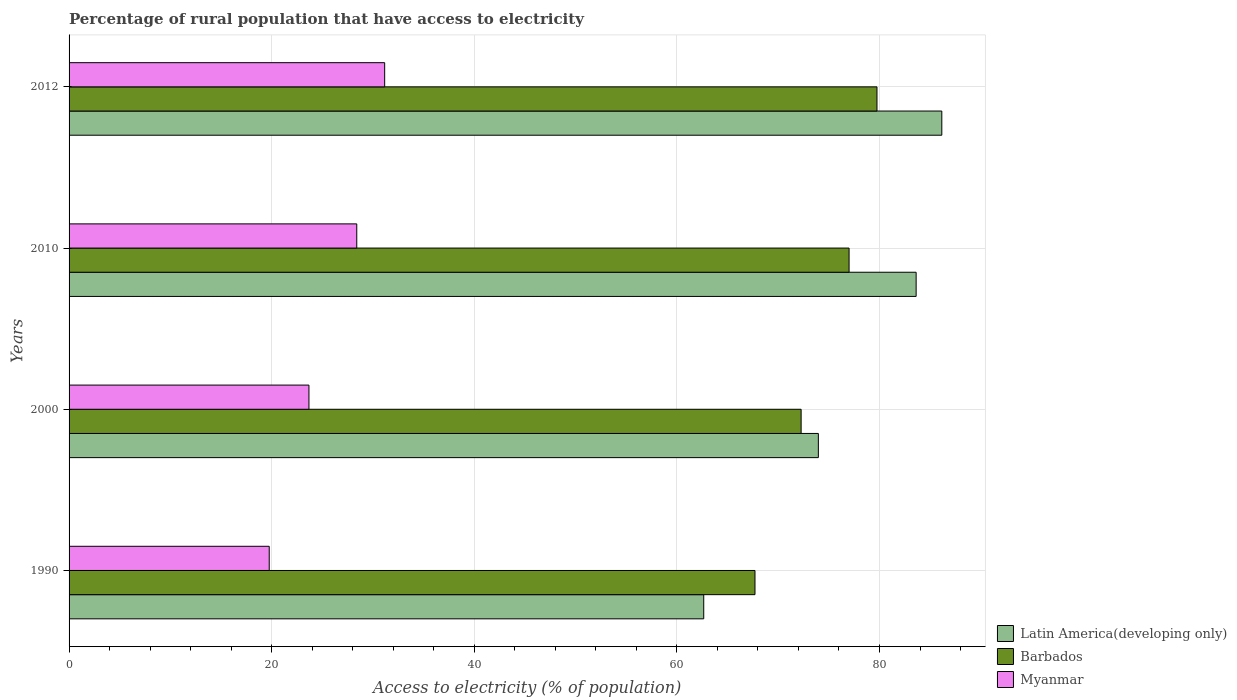How many bars are there on the 2nd tick from the top?
Your response must be concise. 3. How many bars are there on the 4th tick from the bottom?
Offer a very short reply. 3. What is the label of the 3rd group of bars from the top?
Give a very brief answer. 2000. What is the percentage of rural population that have access to electricity in Latin America(developing only) in 1990?
Ensure brevity in your answer.  62.65. Across all years, what is the maximum percentage of rural population that have access to electricity in Barbados?
Your answer should be very brief. 79.75. Across all years, what is the minimum percentage of rural population that have access to electricity in Barbados?
Keep it short and to the point. 67.71. In which year was the percentage of rural population that have access to electricity in Barbados minimum?
Give a very brief answer. 1990. What is the total percentage of rural population that have access to electricity in Latin America(developing only) in the graph?
Ensure brevity in your answer.  306.39. What is the difference between the percentage of rural population that have access to electricity in Barbados in 1990 and that in 2000?
Offer a terse response. -4.55. What is the difference between the percentage of rural population that have access to electricity in Barbados in 1990 and the percentage of rural population that have access to electricity in Myanmar in 2000?
Provide a short and direct response. 44.03. What is the average percentage of rural population that have access to electricity in Barbados per year?
Provide a succinct answer. 74.18. In the year 2000, what is the difference between the percentage of rural population that have access to electricity in Latin America(developing only) and percentage of rural population that have access to electricity in Myanmar?
Offer a very short reply. 50.29. In how many years, is the percentage of rural population that have access to electricity in Barbados greater than 32 %?
Keep it short and to the point. 4. What is the ratio of the percentage of rural population that have access to electricity in Barbados in 1990 to that in 2010?
Keep it short and to the point. 0.88. Is the percentage of rural population that have access to electricity in Myanmar in 1990 less than that in 2012?
Offer a terse response. Yes. Is the difference between the percentage of rural population that have access to electricity in Latin America(developing only) in 2010 and 2012 greater than the difference between the percentage of rural population that have access to electricity in Myanmar in 2010 and 2012?
Provide a short and direct response. Yes. What is the difference between the highest and the second highest percentage of rural population that have access to electricity in Barbados?
Ensure brevity in your answer.  2.75. What is the difference between the highest and the lowest percentage of rural population that have access to electricity in Latin America(developing only)?
Offer a terse response. 23.5. In how many years, is the percentage of rural population that have access to electricity in Myanmar greater than the average percentage of rural population that have access to electricity in Myanmar taken over all years?
Give a very brief answer. 2. Is the sum of the percentage of rural population that have access to electricity in Myanmar in 1990 and 2010 greater than the maximum percentage of rural population that have access to electricity in Latin America(developing only) across all years?
Make the answer very short. No. What does the 2nd bar from the top in 1990 represents?
Provide a short and direct response. Barbados. What does the 2nd bar from the bottom in 2010 represents?
Give a very brief answer. Barbados. Are all the bars in the graph horizontal?
Provide a succinct answer. Yes. What is the difference between two consecutive major ticks on the X-axis?
Ensure brevity in your answer.  20. Does the graph contain any zero values?
Offer a terse response. No. Does the graph contain grids?
Your answer should be very brief. Yes. Where does the legend appear in the graph?
Offer a very short reply. Bottom right. How are the legend labels stacked?
Your answer should be compact. Vertical. What is the title of the graph?
Your answer should be very brief. Percentage of rural population that have access to electricity. Does "Middle East & North Africa (all income levels)" appear as one of the legend labels in the graph?
Provide a succinct answer. No. What is the label or title of the X-axis?
Your answer should be compact. Access to electricity (% of population). What is the label or title of the Y-axis?
Make the answer very short. Years. What is the Access to electricity (% of population) of Latin America(developing only) in 1990?
Provide a succinct answer. 62.65. What is the Access to electricity (% of population) of Barbados in 1990?
Your answer should be very brief. 67.71. What is the Access to electricity (% of population) of Myanmar in 1990?
Make the answer very short. 19.76. What is the Access to electricity (% of population) in Latin America(developing only) in 2000?
Make the answer very short. 73.97. What is the Access to electricity (% of population) of Barbados in 2000?
Your answer should be very brief. 72.27. What is the Access to electricity (% of population) of Myanmar in 2000?
Offer a terse response. 23.68. What is the Access to electricity (% of population) in Latin America(developing only) in 2010?
Your answer should be compact. 83.62. What is the Access to electricity (% of population) in Myanmar in 2010?
Your answer should be compact. 28.4. What is the Access to electricity (% of population) of Latin America(developing only) in 2012?
Make the answer very short. 86.15. What is the Access to electricity (% of population) in Barbados in 2012?
Your answer should be compact. 79.75. What is the Access to electricity (% of population) in Myanmar in 2012?
Your response must be concise. 31.15. Across all years, what is the maximum Access to electricity (% of population) of Latin America(developing only)?
Offer a very short reply. 86.15. Across all years, what is the maximum Access to electricity (% of population) of Barbados?
Provide a short and direct response. 79.75. Across all years, what is the maximum Access to electricity (% of population) of Myanmar?
Your answer should be compact. 31.15. Across all years, what is the minimum Access to electricity (% of population) of Latin America(developing only)?
Keep it short and to the point. 62.65. Across all years, what is the minimum Access to electricity (% of population) of Barbados?
Ensure brevity in your answer.  67.71. Across all years, what is the minimum Access to electricity (% of population) in Myanmar?
Your response must be concise. 19.76. What is the total Access to electricity (% of population) in Latin America(developing only) in the graph?
Your response must be concise. 306.39. What is the total Access to electricity (% of population) of Barbados in the graph?
Your response must be concise. 296.73. What is the total Access to electricity (% of population) in Myanmar in the graph?
Ensure brevity in your answer.  103. What is the difference between the Access to electricity (% of population) of Latin America(developing only) in 1990 and that in 2000?
Provide a succinct answer. -11.32. What is the difference between the Access to electricity (% of population) in Barbados in 1990 and that in 2000?
Keep it short and to the point. -4.55. What is the difference between the Access to electricity (% of population) of Myanmar in 1990 and that in 2000?
Provide a short and direct response. -3.92. What is the difference between the Access to electricity (% of population) in Latin America(developing only) in 1990 and that in 2010?
Provide a succinct answer. -20.97. What is the difference between the Access to electricity (% of population) of Barbados in 1990 and that in 2010?
Ensure brevity in your answer.  -9.29. What is the difference between the Access to electricity (% of population) in Myanmar in 1990 and that in 2010?
Provide a succinct answer. -8.64. What is the difference between the Access to electricity (% of population) in Latin America(developing only) in 1990 and that in 2012?
Provide a succinct answer. -23.5. What is the difference between the Access to electricity (% of population) in Barbados in 1990 and that in 2012?
Your response must be concise. -12.04. What is the difference between the Access to electricity (% of population) of Myanmar in 1990 and that in 2012?
Your answer should be compact. -11.39. What is the difference between the Access to electricity (% of population) in Latin America(developing only) in 2000 and that in 2010?
Keep it short and to the point. -9.65. What is the difference between the Access to electricity (% of population) of Barbados in 2000 and that in 2010?
Ensure brevity in your answer.  -4.74. What is the difference between the Access to electricity (% of population) in Myanmar in 2000 and that in 2010?
Your response must be concise. -4.72. What is the difference between the Access to electricity (% of population) of Latin America(developing only) in 2000 and that in 2012?
Your answer should be very brief. -12.19. What is the difference between the Access to electricity (% of population) of Barbados in 2000 and that in 2012?
Give a very brief answer. -7.49. What is the difference between the Access to electricity (% of population) in Myanmar in 2000 and that in 2012?
Provide a succinct answer. -7.47. What is the difference between the Access to electricity (% of population) of Latin America(developing only) in 2010 and that in 2012?
Keep it short and to the point. -2.53. What is the difference between the Access to electricity (% of population) of Barbados in 2010 and that in 2012?
Provide a short and direct response. -2.75. What is the difference between the Access to electricity (% of population) in Myanmar in 2010 and that in 2012?
Give a very brief answer. -2.75. What is the difference between the Access to electricity (% of population) in Latin America(developing only) in 1990 and the Access to electricity (% of population) in Barbados in 2000?
Your answer should be compact. -9.61. What is the difference between the Access to electricity (% of population) in Latin America(developing only) in 1990 and the Access to electricity (% of population) in Myanmar in 2000?
Your response must be concise. 38.97. What is the difference between the Access to electricity (% of population) of Barbados in 1990 and the Access to electricity (% of population) of Myanmar in 2000?
Your answer should be very brief. 44.03. What is the difference between the Access to electricity (% of population) in Latin America(developing only) in 1990 and the Access to electricity (% of population) in Barbados in 2010?
Keep it short and to the point. -14.35. What is the difference between the Access to electricity (% of population) of Latin America(developing only) in 1990 and the Access to electricity (% of population) of Myanmar in 2010?
Keep it short and to the point. 34.25. What is the difference between the Access to electricity (% of population) of Barbados in 1990 and the Access to electricity (% of population) of Myanmar in 2010?
Offer a very short reply. 39.31. What is the difference between the Access to electricity (% of population) in Latin America(developing only) in 1990 and the Access to electricity (% of population) in Barbados in 2012?
Offer a very short reply. -17.1. What is the difference between the Access to electricity (% of population) in Latin America(developing only) in 1990 and the Access to electricity (% of population) in Myanmar in 2012?
Offer a terse response. 31.5. What is the difference between the Access to electricity (% of population) of Barbados in 1990 and the Access to electricity (% of population) of Myanmar in 2012?
Ensure brevity in your answer.  36.56. What is the difference between the Access to electricity (% of population) of Latin America(developing only) in 2000 and the Access to electricity (% of population) of Barbados in 2010?
Offer a terse response. -3.03. What is the difference between the Access to electricity (% of population) of Latin America(developing only) in 2000 and the Access to electricity (% of population) of Myanmar in 2010?
Your answer should be very brief. 45.57. What is the difference between the Access to electricity (% of population) of Barbados in 2000 and the Access to electricity (% of population) of Myanmar in 2010?
Your response must be concise. 43.87. What is the difference between the Access to electricity (% of population) of Latin America(developing only) in 2000 and the Access to electricity (% of population) of Barbados in 2012?
Keep it short and to the point. -5.79. What is the difference between the Access to electricity (% of population) in Latin America(developing only) in 2000 and the Access to electricity (% of population) in Myanmar in 2012?
Offer a very short reply. 42.81. What is the difference between the Access to electricity (% of population) in Barbados in 2000 and the Access to electricity (% of population) in Myanmar in 2012?
Provide a short and direct response. 41.11. What is the difference between the Access to electricity (% of population) in Latin America(developing only) in 2010 and the Access to electricity (% of population) in Barbados in 2012?
Your response must be concise. 3.86. What is the difference between the Access to electricity (% of population) in Latin America(developing only) in 2010 and the Access to electricity (% of population) in Myanmar in 2012?
Your answer should be very brief. 52.46. What is the difference between the Access to electricity (% of population) of Barbados in 2010 and the Access to electricity (% of population) of Myanmar in 2012?
Offer a terse response. 45.85. What is the average Access to electricity (% of population) of Latin America(developing only) per year?
Offer a very short reply. 76.6. What is the average Access to electricity (% of population) of Barbados per year?
Provide a short and direct response. 74.18. What is the average Access to electricity (% of population) of Myanmar per year?
Keep it short and to the point. 25.75. In the year 1990, what is the difference between the Access to electricity (% of population) of Latin America(developing only) and Access to electricity (% of population) of Barbados?
Provide a short and direct response. -5.06. In the year 1990, what is the difference between the Access to electricity (% of population) in Latin America(developing only) and Access to electricity (% of population) in Myanmar?
Offer a terse response. 42.89. In the year 1990, what is the difference between the Access to electricity (% of population) in Barbados and Access to electricity (% of population) in Myanmar?
Make the answer very short. 47.95. In the year 2000, what is the difference between the Access to electricity (% of population) of Latin America(developing only) and Access to electricity (% of population) of Barbados?
Provide a short and direct response. 1.7. In the year 2000, what is the difference between the Access to electricity (% of population) in Latin America(developing only) and Access to electricity (% of population) in Myanmar?
Your answer should be compact. 50.29. In the year 2000, what is the difference between the Access to electricity (% of population) in Barbados and Access to electricity (% of population) in Myanmar?
Keep it short and to the point. 48.58. In the year 2010, what is the difference between the Access to electricity (% of population) of Latin America(developing only) and Access to electricity (% of population) of Barbados?
Provide a succinct answer. 6.62. In the year 2010, what is the difference between the Access to electricity (% of population) in Latin America(developing only) and Access to electricity (% of population) in Myanmar?
Make the answer very short. 55.22. In the year 2010, what is the difference between the Access to electricity (% of population) in Barbados and Access to electricity (% of population) in Myanmar?
Give a very brief answer. 48.6. In the year 2012, what is the difference between the Access to electricity (% of population) of Latin America(developing only) and Access to electricity (% of population) of Barbados?
Your response must be concise. 6.4. In the year 2012, what is the difference between the Access to electricity (% of population) in Latin America(developing only) and Access to electricity (% of population) in Myanmar?
Keep it short and to the point. 55. In the year 2012, what is the difference between the Access to electricity (% of population) of Barbados and Access to electricity (% of population) of Myanmar?
Offer a very short reply. 48.6. What is the ratio of the Access to electricity (% of population) in Latin America(developing only) in 1990 to that in 2000?
Provide a succinct answer. 0.85. What is the ratio of the Access to electricity (% of population) in Barbados in 1990 to that in 2000?
Provide a succinct answer. 0.94. What is the ratio of the Access to electricity (% of population) of Myanmar in 1990 to that in 2000?
Your response must be concise. 0.83. What is the ratio of the Access to electricity (% of population) of Latin America(developing only) in 1990 to that in 2010?
Provide a short and direct response. 0.75. What is the ratio of the Access to electricity (% of population) of Barbados in 1990 to that in 2010?
Provide a succinct answer. 0.88. What is the ratio of the Access to electricity (% of population) in Myanmar in 1990 to that in 2010?
Provide a succinct answer. 0.7. What is the ratio of the Access to electricity (% of population) in Latin America(developing only) in 1990 to that in 2012?
Keep it short and to the point. 0.73. What is the ratio of the Access to electricity (% of population) in Barbados in 1990 to that in 2012?
Offer a terse response. 0.85. What is the ratio of the Access to electricity (% of population) of Myanmar in 1990 to that in 2012?
Give a very brief answer. 0.63. What is the ratio of the Access to electricity (% of population) of Latin America(developing only) in 2000 to that in 2010?
Provide a succinct answer. 0.88. What is the ratio of the Access to electricity (% of population) in Barbados in 2000 to that in 2010?
Your answer should be compact. 0.94. What is the ratio of the Access to electricity (% of population) of Myanmar in 2000 to that in 2010?
Make the answer very short. 0.83. What is the ratio of the Access to electricity (% of population) of Latin America(developing only) in 2000 to that in 2012?
Make the answer very short. 0.86. What is the ratio of the Access to electricity (% of population) of Barbados in 2000 to that in 2012?
Provide a short and direct response. 0.91. What is the ratio of the Access to electricity (% of population) in Myanmar in 2000 to that in 2012?
Offer a very short reply. 0.76. What is the ratio of the Access to electricity (% of population) of Latin America(developing only) in 2010 to that in 2012?
Offer a very short reply. 0.97. What is the ratio of the Access to electricity (% of population) of Barbados in 2010 to that in 2012?
Offer a terse response. 0.97. What is the ratio of the Access to electricity (% of population) of Myanmar in 2010 to that in 2012?
Your response must be concise. 0.91. What is the difference between the highest and the second highest Access to electricity (% of population) of Latin America(developing only)?
Keep it short and to the point. 2.53. What is the difference between the highest and the second highest Access to electricity (% of population) of Barbados?
Provide a short and direct response. 2.75. What is the difference between the highest and the second highest Access to electricity (% of population) in Myanmar?
Offer a very short reply. 2.75. What is the difference between the highest and the lowest Access to electricity (% of population) of Latin America(developing only)?
Your answer should be very brief. 23.5. What is the difference between the highest and the lowest Access to electricity (% of population) in Barbados?
Provide a short and direct response. 12.04. What is the difference between the highest and the lowest Access to electricity (% of population) in Myanmar?
Make the answer very short. 11.39. 